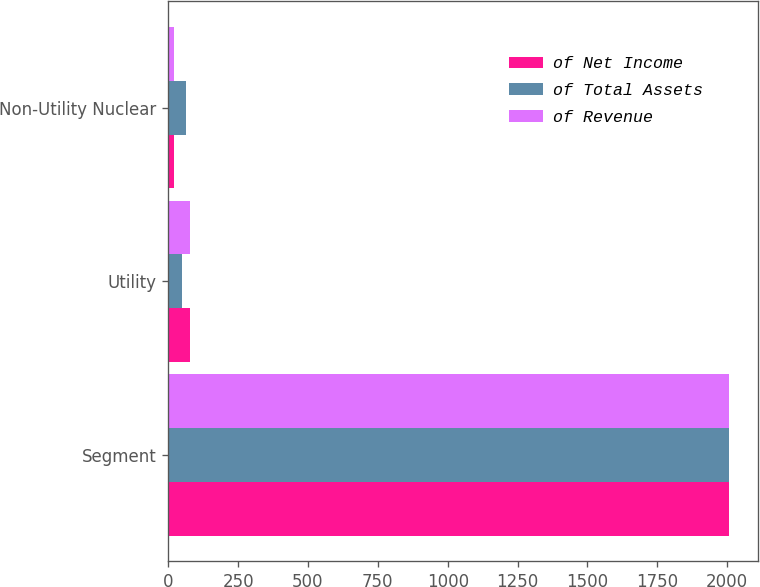Convert chart. <chart><loc_0><loc_0><loc_500><loc_500><stacked_bar_chart><ecel><fcel>Segment<fcel>Utility<fcel>Non-Utility Nuclear<nl><fcel>of Net Income<fcel>2008<fcel>79<fcel>19<nl><fcel>of Total Assets<fcel>2008<fcel>48<fcel>65<nl><fcel>of Revenue<fcel>2008<fcel>79<fcel>21<nl></chart> 